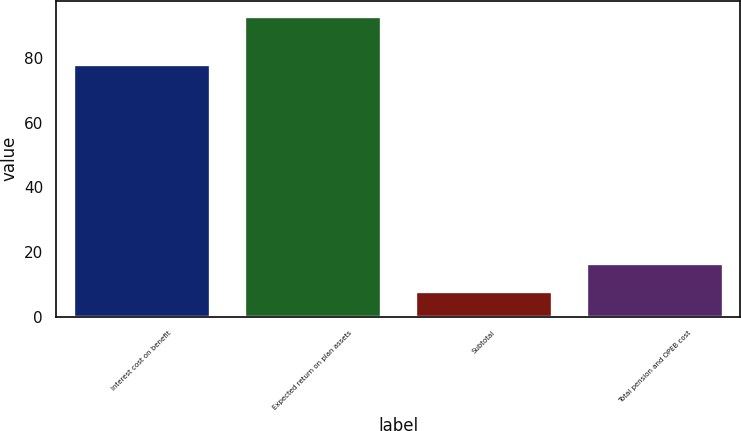Convert chart to OTSL. <chart><loc_0><loc_0><loc_500><loc_500><bar_chart><fcel>Interest cost on benefit<fcel>Expected return on plan assets<fcel>Subtotal<fcel>Total pension and OPEB cost<nl><fcel>78<fcel>93<fcel>8<fcel>16.5<nl></chart> 